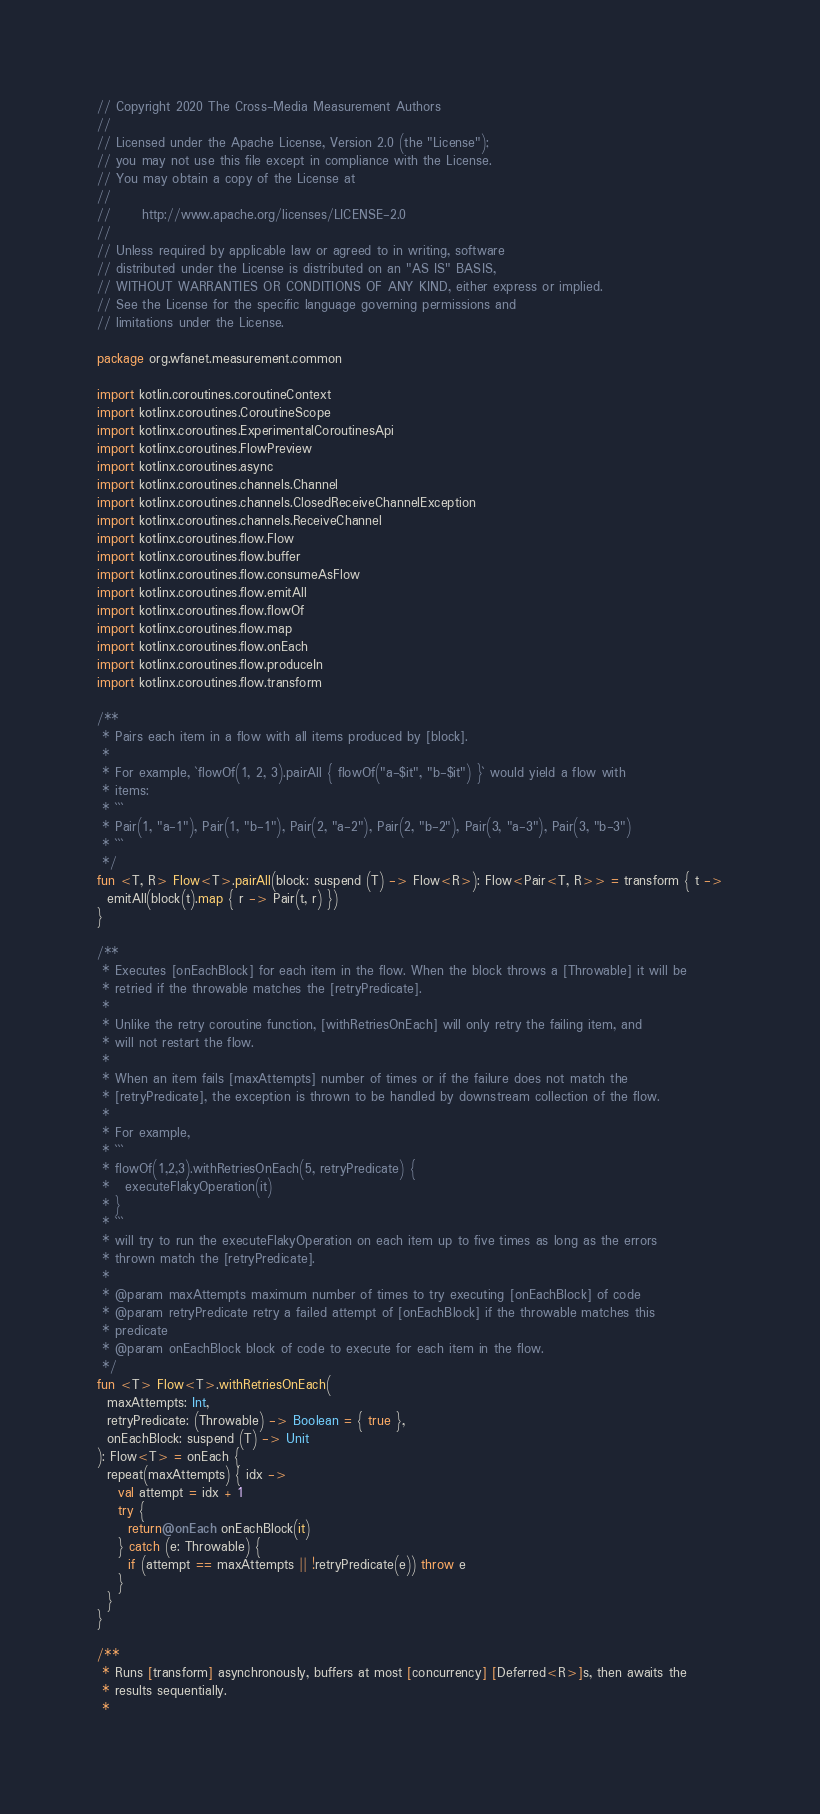Convert code to text. <code><loc_0><loc_0><loc_500><loc_500><_Kotlin_>// Copyright 2020 The Cross-Media Measurement Authors
//
// Licensed under the Apache License, Version 2.0 (the "License");
// you may not use this file except in compliance with the License.
// You may obtain a copy of the License at
//
//      http://www.apache.org/licenses/LICENSE-2.0
//
// Unless required by applicable law or agreed to in writing, software
// distributed under the License is distributed on an "AS IS" BASIS,
// WITHOUT WARRANTIES OR CONDITIONS OF ANY KIND, either express or implied.
// See the License for the specific language governing permissions and
// limitations under the License.

package org.wfanet.measurement.common

import kotlin.coroutines.coroutineContext
import kotlinx.coroutines.CoroutineScope
import kotlinx.coroutines.ExperimentalCoroutinesApi
import kotlinx.coroutines.FlowPreview
import kotlinx.coroutines.async
import kotlinx.coroutines.channels.Channel
import kotlinx.coroutines.channels.ClosedReceiveChannelException
import kotlinx.coroutines.channels.ReceiveChannel
import kotlinx.coroutines.flow.Flow
import kotlinx.coroutines.flow.buffer
import kotlinx.coroutines.flow.consumeAsFlow
import kotlinx.coroutines.flow.emitAll
import kotlinx.coroutines.flow.flowOf
import kotlinx.coroutines.flow.map
import kotlinx.coroutines.flow.onEach
import kotlinx.coroutines.flow.produceIn
import kotlinx.coroutines.flow.transform

/**
 * Pairs each item in a flow with all items produced by [block].
 *
 * For example, `flowOf(1, 2, 3).pairAll { flowOf("a-$it", "b-$it") }` would yield a flow with
 * items:
 * ```
 * Pair(1, "a-1"), Pair(1, "b-1"), Pair(2, "a-2"), Pair(2, "b-2"), Pair(3, "a-3"), Pair(3, "b-3")
 * ```
 */
fun <T, R> Flow<T>.pairAll(block: suspend (T) -> Flow<R>): Flow<Pair<T, R>> = transform { t ->
  emitAll(block(t).map { r -> Pair(t, r) })
}

/**
 * Executes [onEachBlock] for each item in the flow. When the block throws a [Throwable] it will be
 * retried if the throwable matches the [retryPredicate].
 *
 * Unlike the retry coroutine function, [withRetriesOnEach] will only retry the failing item, and
 * will not restart the flow.
 *
 * When an item fails [maxAttempts] number of times or if the failure does not match the
 * [retryPredicate], the exception is thrown to be handled by downstream collection of the flow.
 *
 * For example,
 * ```
 * flowOf(1,2,3).withRetriesOnEach(5, retryPredicate) {
 *   executeFlakyOperation(it)
 * }
 * ```
 * will try to run the executeFlakyOperation on each item up to five times as long as the errors
 * thrown match the [retryPredicate].
 *
 * @param maxAttempts maximum number of times to try executing [onEachBlock] of code
 * @param retryPredicate retry a failed attempt of [onEachBlock] if the throwable matches this
 * predicate
 * @param onEachBlock block of code to execute for each item in the flow.
 */
fun <T> Flow<T>.withRetriesOnEach(
  maxAttempts: Int,
  retryPredicate: (Throwable) -> Boolean = { true },
  onEachBlock: suspend (T) -> Unit
): Flow<T> = onEach {
  repeat(maxAttempts) { idx ->
    val attempt = idx + 1
    try {
      return@onEach onEachBlock(it)
    } catch (e: Throwable) {
      if (attempt == maxAttempts || !retryPredicate(e)) throw e
    }
  }
}

/**
 * Runs [transform] asynchronously, buffers at most [concurrency] [Deferred<R>]s, then awaits the
 * results sequentially.
 *</code> 